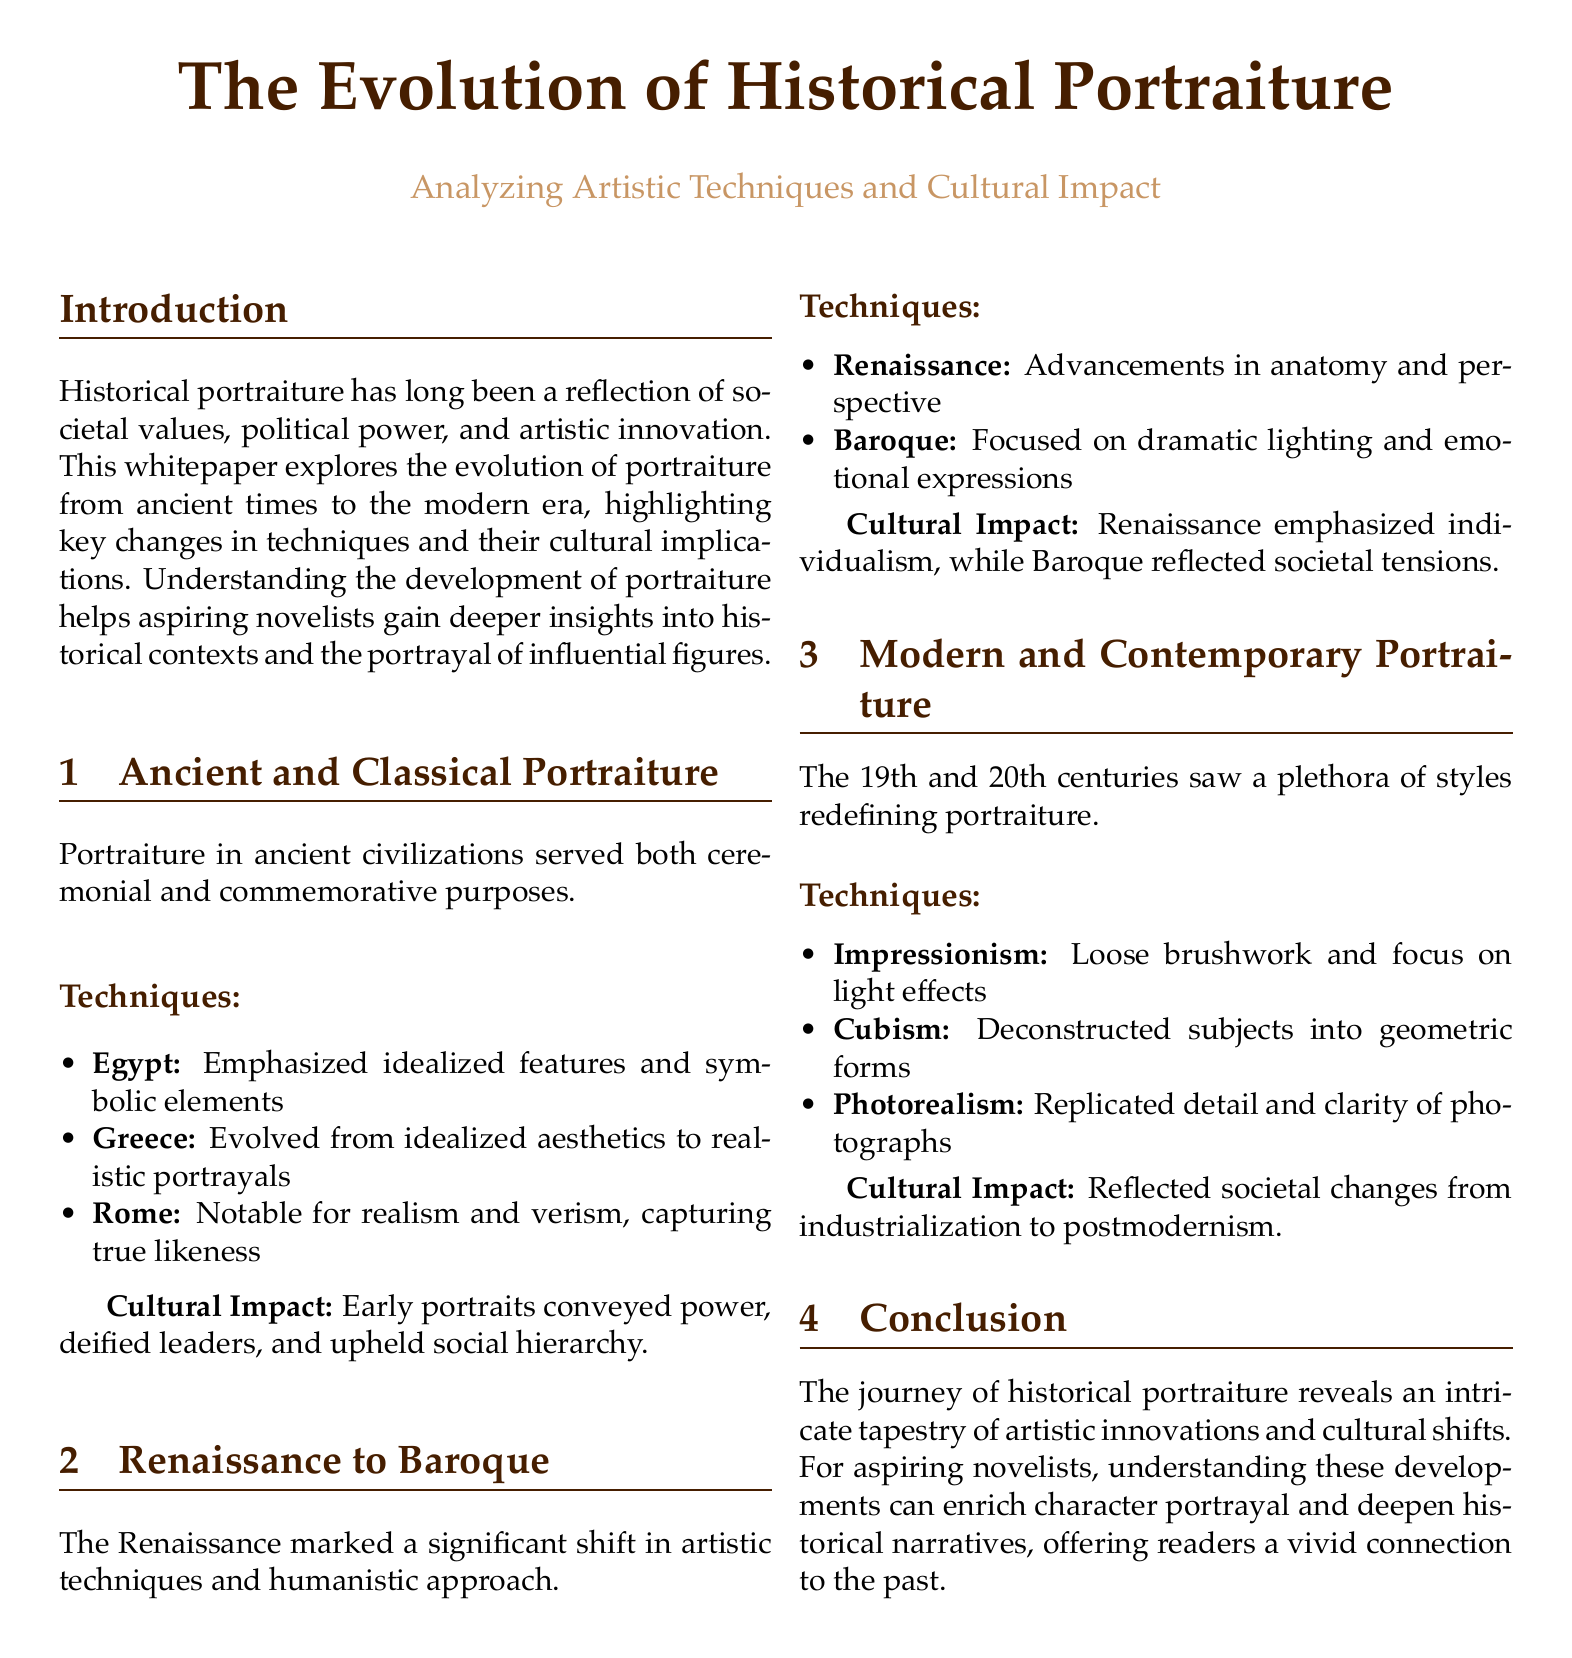What are the ancient civilizations mentioned in the document? The document mentions ancient civilizations that contributed to portraiture, which include Egypt, Greece, and Rome.
Answer: Egypt, Greece, Rome What artistic technique is associated with the Baroque period? The Baroque period is characterized by a focus on dramatic lighting and emotional expressions in portraiture.
Answer: Dramatic lighting What cultural aspect did Renaissance portraiture emphasize? The Renaissance emphasized individualism as a key cultural value reflected in portraiture.
Answer: Individualism What revolutionized portraiture in the 19th and 20th centuries? The document indicates that a plethora of styles emerged in the 19th and 20th centuries that redefined portraiture.
Answer: A plethora of styles How did Classical Rome’s portraiture differ from earlier styles? Roman portraiture is notable for realism and verism, which emphasizes true likeness rather than idealization.
Answer: Realism and verism What role did early portraits serve in ancient civilizations? Early portraits were used primarily for ceremonial and commemorative purposes in ancient civilizations.
Answer: Ceremonial and commemorative What type of brushwork is characteristic of Impressionism? Impressionism is defined by loose brushwork and a focus on the effects of light.
Answer: Loose brushwork Which artistic movement is known for deconstructing subjects into geometric forms? The Cubist movement is identified for its technique of deconstructing subjects into geometric forms.
Answer: Cubism 